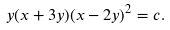<formula> <loc_0><loc_0><loc_500><loc_500>y ( x + 3 y ) ( x - 2 y ) ^ { 2 } = c .</formula> 